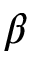Convert formula to latex. <formula><loc_0><loc_0><loc_500><loc_500>\beta</formula> 